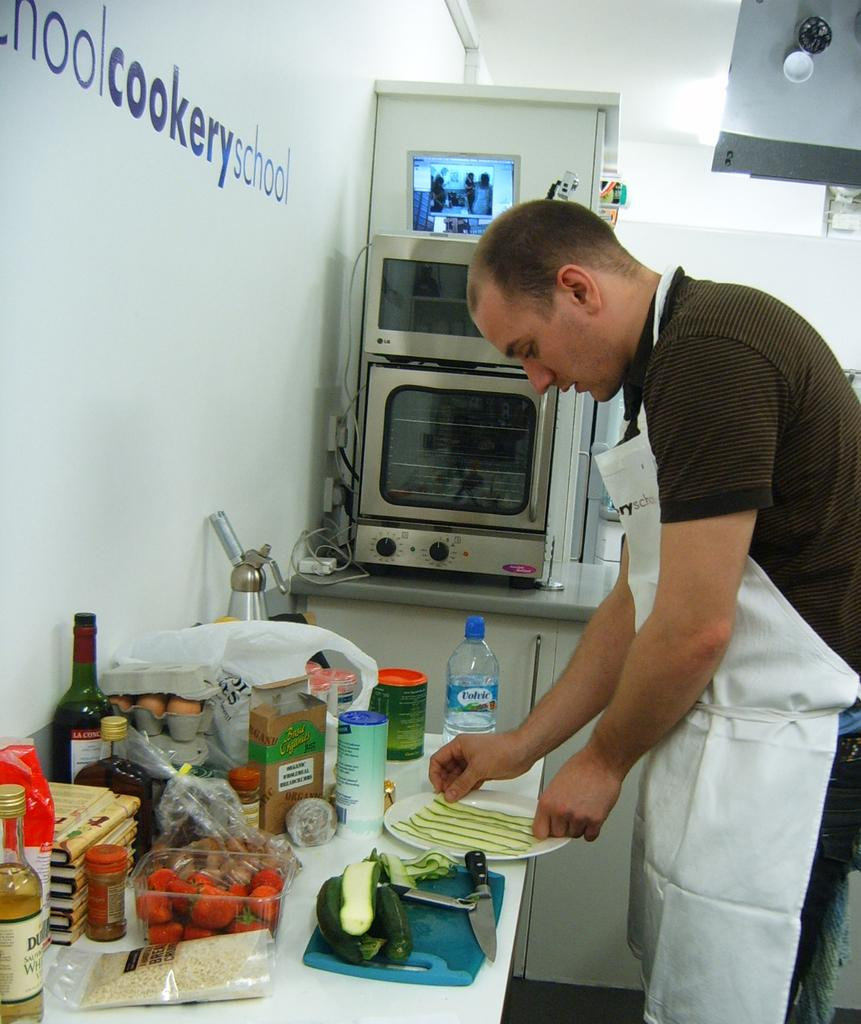<image>
Write a terse but informative summary of the picture. A man prepares food next to a wall that says "cookery school." 